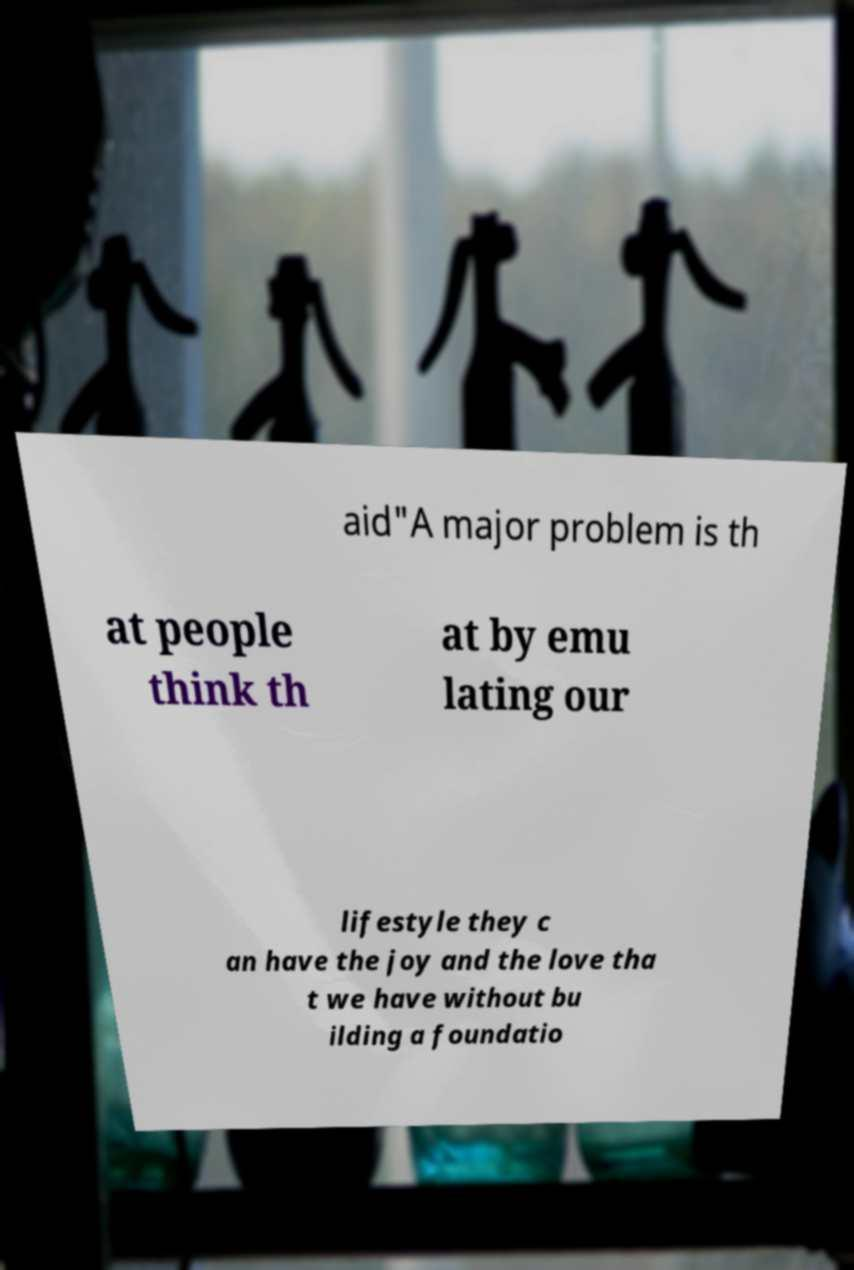What messages or text are displayed in this image? I need them in a readable, typed format. aid"A major problem is th at people think th at by emu lating our lifestyle they c an have the joy and the love tha t we have without bu ilding a foundatio 